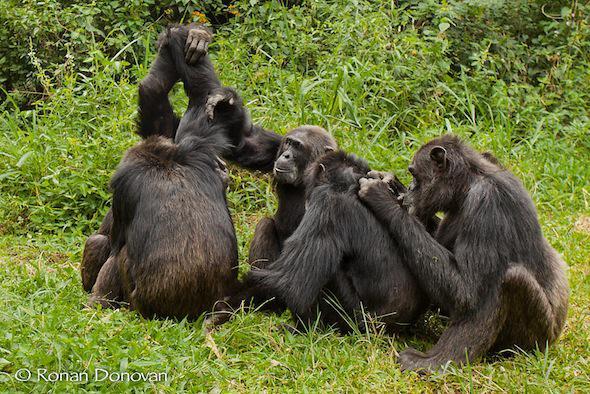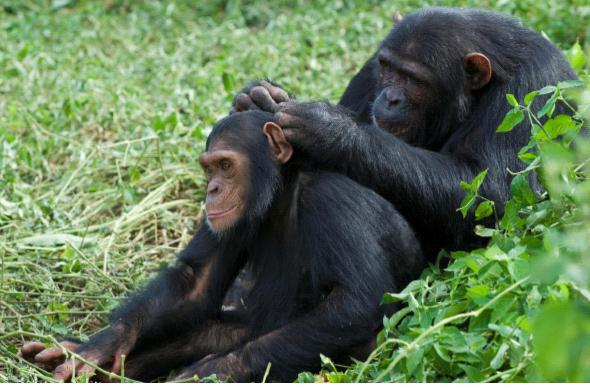The first image is the image on the left, the second image is the image on the right. For the images shown, is this caption "An image shows two rightward-facing apes, with one sitting behind the other." true? Answer yes or no. No. The first image is the image on the left, the second image is the image on the right. For the images displayed, is the sentence "There are exactly three gorillas huddled together in the image on the left." factually correct? Answer yes or no. No. 